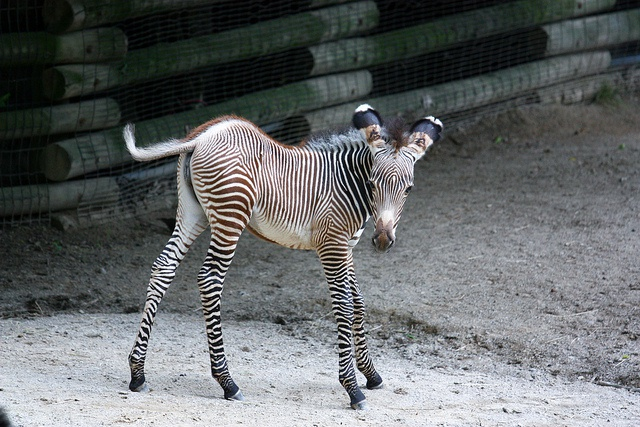Describe the objects in this image and their specific colors. I can see a zebra in black, darkgray, lightgray, and gray tones in this image. 